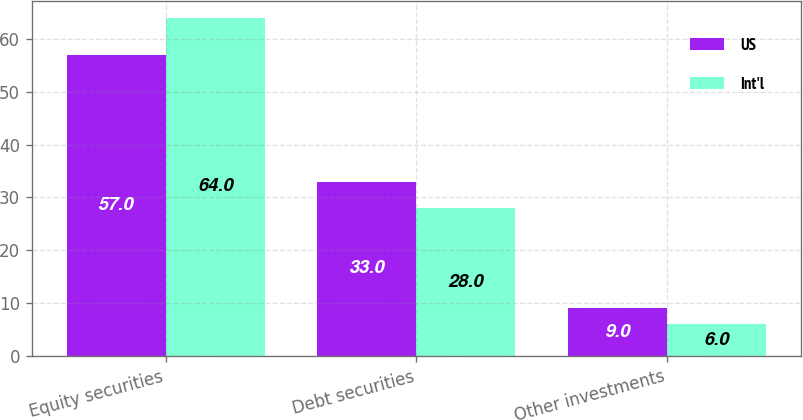Convert chart to OTSL. <chart><loc_0><loc_0><loc_500><loc_500><stacked_bar_chart><ecel><fcel>Equity securities<fcel>Debt securities<fcel>Other investments<nl><fcel>US<fcel>57<fcel>33<fcel>9<nl><fcel>Int'l<fcel>64<fcel>28<fcel>6<nl></chart> 